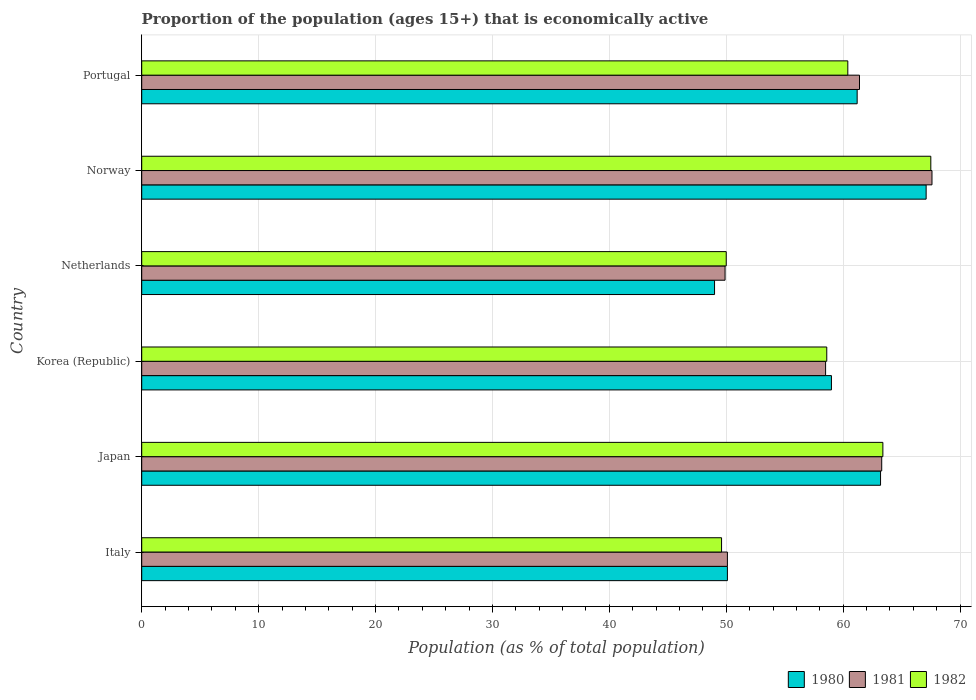How many groups of bars are there?
Ensure brevity in your answer.  6. Are the number of bars per tick equal to the number of legend labels?
Your answer should be very brief. Yes. How many bars are there on the 1st tick from the top?
Provide a succinct answer. 3. How many bars are there on the 5th tick from the bottom?
Your answer should be compact. 3. What is the proportion of the population that is economically active in 1982 in Norway?
Ensure brevity in your answer.  67.5. Across all countries, what is the maximum proportion of the population that is economically active in 1982?
Provide a short and direct response. 67.5. In which country was the proportion of the population that is economically active in 1982 maximum?
Keep it short and to the point. Norway. What is the total proportion of the population that is economically active in 1982 in the graph?
Offer a terse response. 349.5. What is the difference between the proportion of the population that is economically active in 1981 in Netherlands and that in Norway?
Provide a short and direct response. -17.7. What is the difference between the proportion of the population that is economically active in 1982 in Netherlands and the proportion of the population that is economically active in 1981 in Italy?
Ensure brevity in your answer.  -0.1. What is the average proportion of the population that is economically active in 1981 per country?
Make the answer very short. 58.47. What is the difference between the proportion of the population that is economically active in 1981 and proportion of the population that is economically active in 1980 in Portugal?
Provide a succinct answer. 0.2. What is the ratio of the proportion of the population that is economically active in 1980 in Norway to that in Portugal?
Provide a succinct answer. 1.1. Is the proportion of the population that is economically active in 1981 in Netherlands less than that in Portugal?
Your answer should be very brief. Yes. What is the difference between the highest and the second highest proportion of the population that is economically active in 1980?
Offer a very short reply. 3.9. What is the difference between the highest and the lowest proportion of the population that is economically active in 1981?
Give a very brief answer. 17.7. In how many countries, is the proportion of the population that is economically active in 1980 greater than the average proportion of the population that is economically active in 1980 taken over all countries?
Keep it short and to the point. 4. How many bars are there?
Your answer should be very brief. 18. How many countries are there in the graph?
Your answer should be compact. 6. What is the difference between two consecutive major ticks on the X-axis?
Your answer should be compact. 10. Does the graph contain any zero values?
Give a very brief answer. No. Where does the legend appear in the graph?
Keep it short and to the point. Bottom right. How many legend labels are there?
Your answer should be very brief. 3. What is the title of the graph?
Keep it short and to the point. Proportion of the population (ages 15+) that is economically active. What is the label or title of the X-axis?
Give a very brief answer. Population (as % of total population). What is the Population (as % of total population) of 1980 in Italy?
Make the answer very short. 50.1. What is the Population (as % of total population) in 1981 in Italy?
Your answer should be very brief. 50.1. What is the Population (as % of total population) in 1982 in Italy?
Keep it short and to the point. 49.6. What is the Population (as % of total population) in 1980 in Japan?
Give a very brief answer. 63.2. What is the Population (as % of total population) of 1981 in Japan?
Provide a succinct answer. 63.3. What is the Population (as % of total population) in 1982 in Japan?
Offer a very short reply. 63.4. What is the Population (as % of total population) of 1980 in Korea (Republic)?
Keep it short and to the point. 59. What is the Population (as % of total population) of 1981 in Korea (Republic)?
Give a very brief answer. 58.5. What is the Population (as % of total population) of 1982 in Korea (Republic)?
Keep it short and to the point. 58.6. What is the Population (as % of total population) of 1980 in Netherlands?
Keep it short and to the point. 49. What is the Population (as % of total population) of 1981 in Netherlands?
Your answer should be very brief. 49.9. What is the Population (as % of total population) in 1980 in Norway?
Your answer should be very brief. 67.1. What is the Population (as % of total population) of 1981 in Norway?
Your response must be concise. 67.6. What is the Population (as % of total population) in 1982 in Norway?
Your answer should be very brief. 67.5. What is the Population (as % of total population) of 1980 in Portugal?
Make the answer very short. 61.2. What is the Population (as % of total population) of 1981 in Portugal?
Your answer should be compact. 61.4. What is the Population (as % of total population) of 1982 in Portugal?
Provide a short and direct response. 60.4. Across all countries, what is the maximum Population (as % of total population) of 1980?
Give a very brief answer. 67.1. Across all countries, what is the maximum Population (as % of total population) in 1981?
Your response must be concise. 67.6. Across all countries, what is the maximum Population (as % of total population) of 1982?
Make the answer very short. 67.5. Across all countries, what is the minimum Population (as % of total population) of 1980?
Keep it short and to the point. 49. Across all countries, what is the minimum Population (as % of total population) of 1981?
Give a very brief answer. 49.9. Across all countries, what is the minimum Population (as % of total population) in 1982?
Offer a very short reply. 49.6. What is the total Population (as % of total population) of 1980 in the graph?
Offer a terse response. 349.6. What is the total Population (as % of total population) of 1981 in the graph?
Ensure brevity in your answer.  350.8. What is the total Population (as % of total population) in 1982 in the graph?
Offer a very short reply. 349.5. What is the difference between the Population (as % of total population) of 1980 in Italy and that in Japan?
Keep it short and to the point. -13.1. What is the difference between the Population (as % of total population) in 1981 in Italy and that in Japan?
Make the answer very short. -13.2. What is the difference between the Population (as % of total population) of 1980 in Italy and that in Korea (Republic)?
Keep it short and to the point. -8.9. What is the difference between the Population (as % of total population) of 1982 in Italy and that in Korea (Republic)?
Ensure brevity in your answer.  -9. What is the difference between the Population (as % of total population) in 1982 in Italy and that in Netherlands?
Your answer should be very brief. -0.4. What is the difference between the Population (as % of total population) of 1980 in Italy and that in Norway?
Make the answer very short. -17. What is the difference between the Population (as % of total population) of 1981 in Italy and that in Norway?
Offer a very short reply. -17.5. What is the difference between the Population (as % of total population) in 1982 in Italy and that in Norway?
Make the answer very short. -17.9. What is the difference between the Population (as % of total population) of 1980 in Italy and that in Portugal?
Keep it short and to the point. -11.1. What is the difference between the Population (as % of total population) of 1981 in Italy and that in Portugal?
Make the answer very short. -11.3. What is the difference between the Population (as % of total population) of 1982 in Italy and that in Portugal?
Offer a very short reply. -10.8. What is the difference between the Population (as % of total population) in 1981 in Japan and that in Korea (Republic)?
Your answer should be compact. 4.8. What is the difference between the Population (as % of total population) in 1980 in Japan and that in Netherlands?
Ensure brevity in your answer.  14.2. What is the difference between the Population (as % of total population) in 1981 in Japan and that in Netherlands?
Provide a short and direct response. 13.4. What is the difference between the Population (as % of total population) of 1982 in Japan and that in Netherlands?
Your answer should be very brief. 13.4. What is the difference between the Population (as % of total population) of 1980 in Japan and that in Norway?
Offer a very short reply. -3.9. What is the difference between the Population (as % of total population) in 1981 in Japan and that in Norway?
Provide a short and direct response. -4.3. What is the difference between the Population (as % of total population) of 1980 in Japan and that in Portugal?
Give a very brief answer. 2. What is the difference between the Population (as % of total population) in 1981 in Japan and that in Portugal?
Offer a very short reply. 1.9. What is the difference between the Population (as % of total population) in 1982 in Japan and that in Portugal?
Your answer should be compact. 3. What is the difference between the Population (as % of total population) in 1981 in Korea (Republic) and that in Netherlands?
Your answer should be very brief. 8.6. What is the difference between the Population (as % of total population) of 1982 in Korea (Republic) and that in Netherlands?
Offer a terse response. 8.6. What is the difference between the Population (as % of total population) of 1980 in Korea (Republic) and that in Norway?
Ensure brevity in your answer.  -8.1. What is the difference between the Population (as % of total population) of 1982 in Korea (Republic) and that in Norway?
Offer a terse response. -8.9. What is the difference between the Population (as % of total population) in 1980 in Korea (Republic) and that in Portugal?
Ensure brevity in your answer.  -2.2. What is the difference between the Population (as % of total population) in 1981 in Korea (Republic) and that in Portugal?
Give a very brief answer. -2.9. What is the difference between the Population (as % of total population) in 1980 in Netherlands and that in Norway?
Your response must be concise. -18.1. What is the difference between the Population (as % of total population) of 1981 in Netherlands and that in Norway?
Provide a succinct answer. -17.7. What is the difference between the Population (as % of total population) of 1982 in Netherlands and that in Norway?
Your answer should be compact. -17.5. What is the difference between the Population (as % of total population) of 1980 in Netherlands and that in Portugal?
Keep it short and to the point. -12.2. What is the difference between the Population (as % of total population) in 1981 in Netherlands and that in Portugal?
Give a very brief answer. -11.5. What is the difference between the Population (as % of total population) in 1982 in Netherlands and that in Portugal?
Your answer should be very brief. -10.4. What is the difference between the Population (as % of total population) of 1980 in Italy and the Population (as % of total population) of 1982 in Japan?
Give a very brief answer. -13.3. What is the difference between the Population (as % of total population) of 1981 in Italy and the Population (as % of total population) of 1982 in Korea (Republic)?
Ensure brevity in your answer.  -8.5. What is the difference between the Population (as % of total population) in 1980 in Italy and the Population (as % of total population) in 1981 in Netherlands?
Your response must be concise. 0.2. What is the difference between the Population (as % of total population) in 1980 in Italy and the Population (as % of total population) in 1982 in Netherlands?
Offer a terse response. 0.1. What is the difference between the Population (as % of total population) of 1980 in Italy and the Population (as % of total population) of 1981 in Norway?
Provide a short and direct response. -17.5. What is the difference between the Population (as % of total population) of 1980 in Italy and the Population (as % of total population) of 1982 in Norway?
Provide a short and direct response. -17.4. What is the difference between the Population (as % of total population) in 1981 in Italy and the Population (as % of total population) in 1982 in Norway?
Ensure brevity in your answer.  -17.4. What is the difference between the Population (as % of total population) in 1980 in Japan and the Population (as % of total population) in 1982 in Korea (Republic)?
Provide a succinct answer. 4.6. What is the difference between the Population (as % of total population) of 1980 in Japan and the Population (as % of total population) of 1981 in Netherlands?
Your response must be concise. 13.3. What is the difference between the Population (as % of total population) of 1980 in Japan and the Population (as % of total population) of 1982 in Netherlands?
Make the answer very short. 13.2. What is the difference between the Population (as % of total population) of 1981 in Japan and the Population (as % of total population) of 1982 in Netherlands?
Provide a short and direct response. 13.3. What is the difference between the Population (as % of total population) in 1981 in Japan and the Population (as % of total population) in 1982 in Portugal?
Your response must be concise. 2.9. What is the difference between the Population (as % of total population) in 1980 in Korea (Republic) and the Population (as % of total population) in 1981 in Netherlands?
Your answer should be compact. 9.1. What is the difference between the Population (as % of total population) of 1980 in Korea (Republic) and the Population (as % of total population) of 1982 in Netherlands?
Give a very brief answer. 9. What is the difference between the Population (as % of total population) in 1980 in Korea (Republic) and the Population (as % of total population) in 1982 in Norway?
Ensure brevity in your answer.  -8.5. What is the difference between the Population (as % of total population) in 1980 in Netherlands and the Population (as % of total population) in 1981 in Norway?
Give a very brief answer. -18.6. What is the difference between the Population (as % of total population) in 1980 in Netherlands and the Population (as % of total population) in 1982 in Norway?
Give a very brief answer. -18.5. What is the difference between the Population (as % of total population) of 1981 in Netherlands and the Population (as % of total population) of 1982 in Norway?
Keep it short and to the point. -17.6. What is the difference between the Population (as % of total population) of 1980 in Netherlands and the Population (as % of total population) of 1981 in Portugal?
Your answer should be very brief. -12.4. What is the difference between the Population (as % of total population) of 1980 in Netherlands and the Population (as % of total population) of 1982 in Portugal?
Keep it short and to the point. -11.4. What is the average Population (as % of total population) of 1980 per country?
Ensure brevity in your answer.  58.27. What is the average Population (as % of total population) in 1981 per country?
Give a very brief answer. 58.47. What is the average Population (as % of total population) of 1982 per country?
Your answer should be compact. 58.25. What is the difference between the Population (as % of total population) of 1980 and Population (as % of total population) of 1981 in Italy?
Your response must be concise. 0. What is the difference between the Population (as % of total population) in 1981 and Population (as % of total population) in 1982 in Italy?
Your response must be concise. 0.5. What is the difference between the Population (as % of total population) in 1980 and Population (as % of total population) in 1981 in Japan?
Your answer should be very brief. -0.1. What is the difference between the Population (as % of total population) of 1981 and Population (as % of total population) of 1982 in Japan?
Ensure brevity in your answer.  -0.1. What is the difference between the Population (as % of total population) in 1980 and Population (as % of total population) in 1981 in Netherlands?
Your response must be concise. -0.9. What is the difference between the Population (as % of total population) in 1980 and Population (as % of total population) in 1982 in Netherlands?
Provide a succinct answer. -1. What is the difference between the Population (as % of total population) in 1981 and Population (as % of total population) in 1982 in Netherlands?
Provide a succinct answer. -0.1. What is the difference between the Population (as % of total population) of 1980 and Population (as % of total population) of 1982 in Norway?
Keep it short and to the point. -0.4. What is the ratio of the Population (as % of total population) of 1980 in Italy to that in Japan?
Provide a succinct answer. 0.79. What is the ratio of the Population (as % of total population) of 1981 in Italy to that in Japan?
Give a very brief answer. 0.79. What is the ratio of the Population (as % of total population) of 1982 in Italy to that in Japan?
Offer a terse response. 0.78. What is the ratio of the Population (as % of total population) of 1980 in Italy to that in Korea (Republic)?
Offer a terse response. 0.85. What is the ratio of the Population (as % of total population) in 1981 in Italy to that in Korea (Republic)?
Give a very brief answer. 0.86. What is the ratio of the Population (as % of total population) of 1982 in Italy to that in Korea (Republic)?
Make the answer very short. 0.85. What is the ratio of the Population (as % of total population) in 1980 in Italy to that in Netherlands?
Make the answer very short. 1.02. What is the ratio of the Population (as % of total population) in 1982 in Italy to that in Netherlands?
Ensure brevity in your answer.  0.99. What is the ratio of the Population (as % of total population) of 1980 in Italy to that in Norway?
Your answer should be very brief. 0.75. What is the ratio of the Population (as % of total population) of 1981 in Italy to that in Norway?
Ensure brevity in your answer.  0.74. What is the ratio of the Population (as % of total population) of 1982 in Italy to that in Norway?
Give a very brief answer. 0.73. What is the ratio of the Population (as % of total population) of 1980 in Italy to that in Portugal?
Make the answer very short. 0.82. What is the ratio of the Population (as % of total population) of 1981 in Italy to that in Portugal?
Ensure brevity in your answer.  0.82. What is the ratio of the Population (as % of total population) in 1982 in Italy to that in Portugal?
Make the answer very short. 0.82. What is the ratio of the Population (as % of total population) of 1980 in Japan to that in Korea (Republic)?
Give a very brief answer. 1.07. What is the ratio of the Population (as % of total population) of 1981 in Japan to that in Korea (Republic)?
Provide a short and direct response. 1.08. What is the ratio of the Population (as % of total population) of 1982 in Japan to that in Korea (Republic)?
Provide a short and direct response. 1.08. What is the ratio of the Population (as % of total population) in 1980 in Japan to that in Netherlands?
Provide a short and direct response. 1.29. What is the ratio of the Population (as % of total population) in 1981 in Japan to that in Netherlands?
Provide a short and direct response. 1.27. What is the ratio of the Population (as % of total population) of 1982 in Japan to that in Netherlands?
Offer a very short reply. 1.27. What is the ratio of the Population (as % of total population) in 1980 in Japan to that in Norway?
Your response must be concise. 0.94. What is the ratio of the Population (as % of total population) in 1981 in Japan to that in Norway?
Your response must be concise. 0.94. What is the ratio of the Population (as % of total population) in 1982 in Japan to that in Norway?
Your answer should be compact. 0.94. What is the ratio of the Population (as % of total population) in 1980 in Japan to that in Portugal?
Your answer should be very brief. 1.03. What is the ratio of the Population (as % of total population) of 1981 in Japan to that in Portugal?
Make the answer very short. 1.03. What is the ratio of the Population (as % of total population) in 1982 in Japan to that in Portugal?
Provide a succinct answer. 1.05. What is the ratio of the Population (as % of total population) in 1980 in Korea (Republic) to that in Netherlands?
Ensure brevity in your answer.  1.2. What is the ratio of the Population (as % of total population) in 1981 in Korea (Republic) to that in Netherlands?
Give a very brief answer. 1.17. What is the ratio of the Population (as % of total population) of 1982 in Korea (Republic) to that in Netherlands?
Provide a succinct answer. 1.17. What is the ratio of the Population (as % of total population) of 1980 in Korea (Republic) to that in Norway?
Keep it short and to the point. 0.88. What is the ratio of the Population (as % of total population) in 1981 in Korea (Republic) to that in Norway?
Give a very brief answer. 0.87. What is the ratio of the Population (as % of total population) of 1982 in Korea (Republic) to that in Norway?
Keep it short and to the point. 0.87. What is the ratio of the Population (as % of total population) in 1980 in Korea (Republic) to that in Portugal?
Your response must be concise. 0.96. What is the ratio of the Population (as % of total population) of 1981 in Korea (Republic) to that in Portugal?
Your answer should be very brief. 0.95. What is the ratio of the Population (as % of total population) of 1982 in Korea (Republic) to that in Portugal?
Provide a succinct answer. 0.97. What is the ratio of the Population (as % of total population) in 1980 in Netherlands to that in Norway?
Provide a succinct answer. 0.73. What is the ratio of the Population (as % of total population) of 1981 in Netherlands to that in Norway?
Give a very brief answer. 0.74. What is the ratio of the Population (as % of total population) of 1982 in Netherlands to that in Norway?
Make the answer very short. 0.74. What is the ratio of the Population (as % of total population) in 1980 in Netherlands to that in Portugal?
Make the answer very short. 0.8. What is the ratio of the Population (as % of total population) of 1981 in Netherlands to that in Portugal?
Offer a terse response. 0.81. What is the ratio of the Population (as % of total population) in 1982 in Netherlands to that in Portugal?
Offer a terse response. 0.83. What is the ratio of the Population (as % of total population) of 1980 in Norway to that in Portugal?
Your response must be concise. 1.1. What is the ratio of the Population (as % of total population) in 1981 in Norway to that in Portugal?
Your answer should be compact. 1.1. What is the ratio of the Population (as % of total population) in 1982 in Norway to that in Portugal?
Offer a very short reply. 1.12. What is the difference between the highest and the second highest Population (as % of total population) of 1980?
Ensure brevity in your answer.  3.9. What is the difference between the highest and the lowest Population (as % of total population) of 1980?
Your answer should be compact. 18.1. 